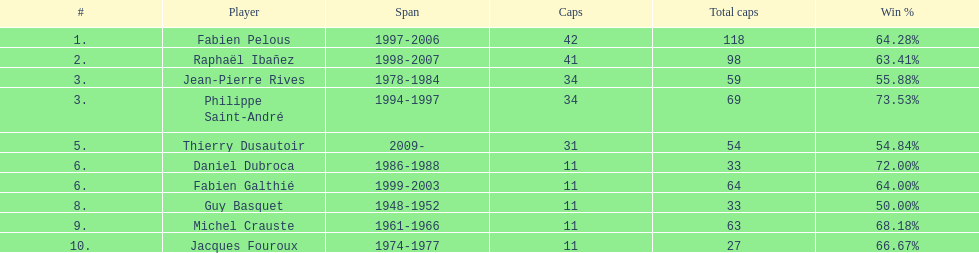Single player to serve in the role of captain from 1998-2007 Raphaël Ibañez. 